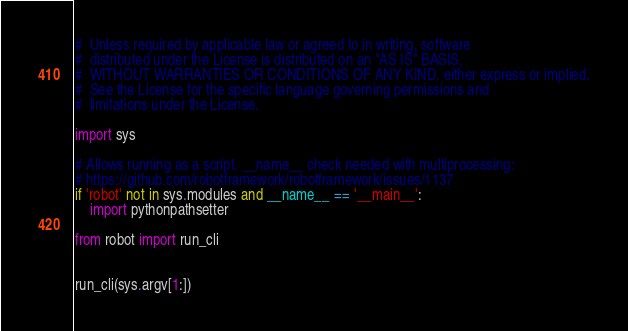<code> <loc_0><loc_0><loc_500><loc_500><_Python_>#  Unless required by applicable law or agreed to in writing, software
#  distributed under the License is distributed on an "AS IS" BASIS,
#  WITHOUT WARRANTIES OR CONDITIONS OF ANY KIND, either express or implied.
#  See the License for the specific language governing permissions and
#  limitations under the License.

import sys

# Allows running as a script. __name__ check needed with multiprocessing:
# https://github.com/robotframework/robotframework/issues/1137
if 'robot' not in sys.modules and __name__ == '__main__':
    import pythonpathsetter

from robot import run_cli


run_cli(sys.argv[1:])
</code> 